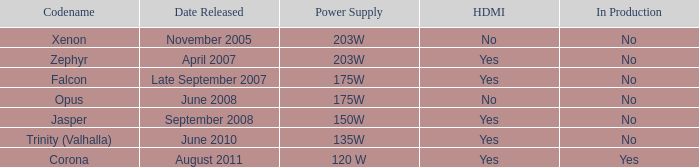Is Jasper being producted? No. Could you help me parse every detail presented in this table? {'header': ['Codename', 'Date Released', 'Power Supply', 'HDMI', 'In Production'], 'rows': [['Xenon', 'November 2005', '203W', 'No', 'No'], ['Zephyr', 'April 2007', '203W', 'Yes', 'No'], ['Falcon', 'Late September 2007', '175W', 'Yes', 'No'], ['Opus', 'June 2008', '175W', 'No', 'No'], ['Jasper', 'September 2008', '150W', 'Yes', 'No'], ['Trinity (Valhalla)', 'June 2010', '135W', 'Yes', 'No'], ['Corona', 'August 2011', '120 W', 'Yes', 'Yes']]} 